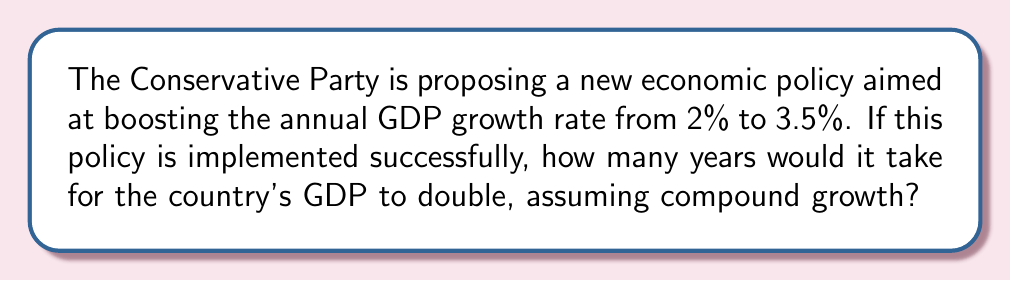What is the answer to this math problem? To solve this problem, we'll use the compound interest formula and the concept of doubling time.

1. The compound interest formula is:
   $$A = P(1 + r)^t$$
   where A is the final amount, P is the initial principal, r is the annual growth rate, and t is the time in years.

2. For doubling, we want A = 2P. Substituting this into the formula:
   $$2P = P(1 + r)^t$$

3. Simplify by dividing both sides by P:
   $$2 = (1 + r)^t$$

4. Take the natural logarithm of both sides:
   $$\ln(2) = t \cdot \ln(1 + r)$$

5. Solve for t:
   $$t = \frac{\ln(2)}{\ln(1 + r)}$$

6. This is the formula for doubling time. Now, let's plug in our growth rate of 3.5% (0.035):
   $$t = \frac{\ln(2)}{\ln(1 + 0.035)}$$

7. Calculate:
   $$t = \frac{0.6931}{0.0344} \approx 20.15$$

8. Round to the nearest whole year:
   $$t \approx 20\text{ years}$$
Answer: 20 years 